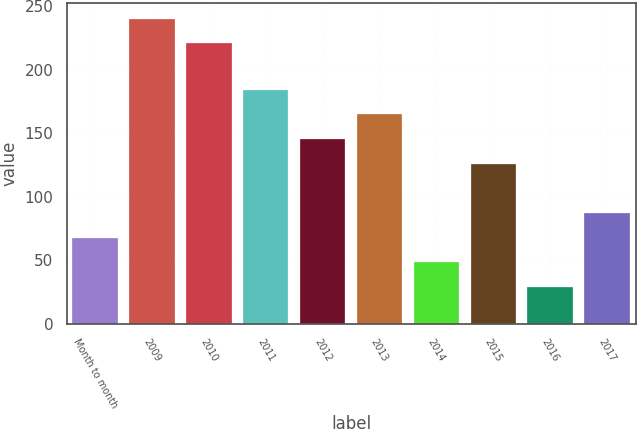<chart> <loc_0><loc_0><loc_500><loc_500><bar_chart><fcel>Month to month<fcel>2009<fcel>2010<fcel>2011<fcel>2012<fcel>2013<fcel>2014<fcel>2015<fcel>2016<fcel>2017<nl><fcel>67.8<fcel>240.4<fcel>221<fcel>184.2<fcel>145.4<fcel>164.8<fcel>48.4<fcel>126<fcel>29<fcel>87.2<nl></chart> 